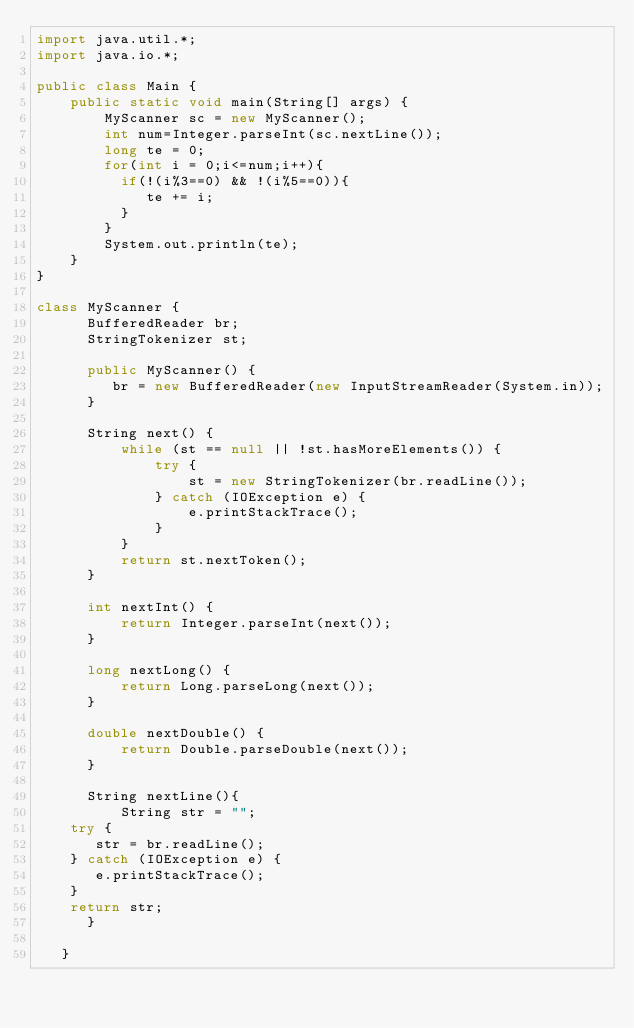Convert code to text. <code><loc_0><loc_0><loc_500><loc_500><_Java_>import java.util.*;
import java.io.*;

public class Main {
    public static void main(String[] args) {
    	MyScanner sc = new MyScanner();
   		int num=Integer.parseInt(sc.nextLine());
		long te = 0;
      	for(int i = 0;i<=num;i++){
          if(!(i%3==0) && !(i%5==0)){
             te += i;
          }
        }
      	System.out.println(te);
    }
}

class MyScanner {
      BufferedReader br;
      StringTokenizer st;
 
      public MyScanner() {
         br = new BufferedReader(new InputStreamReader(System.in));
      }
 
      String next() {
          while (st == null || !st.hasMoreElements()) {
              try {
                  st = new StringTokenizer(br.readLine());
              } catch (IOException e) {
                  e.printStackTrace();
              }
          }
          return st.nextToken();
      }
 
      int nextInt() {
          return Integer.parseInt(next());
      }
 
      long nextLong() {
          return Long.parseLong(next());
      }
 
      double nextDouble() {
          return Double.parseDouble(next());
      }
 
      String nextLine(){
          String str = "";
    try {
       str = br.readLine();
    } catch (IOException e) {
       e.printStackTrace();
    }
    return str;
      }
 
   }</code> 